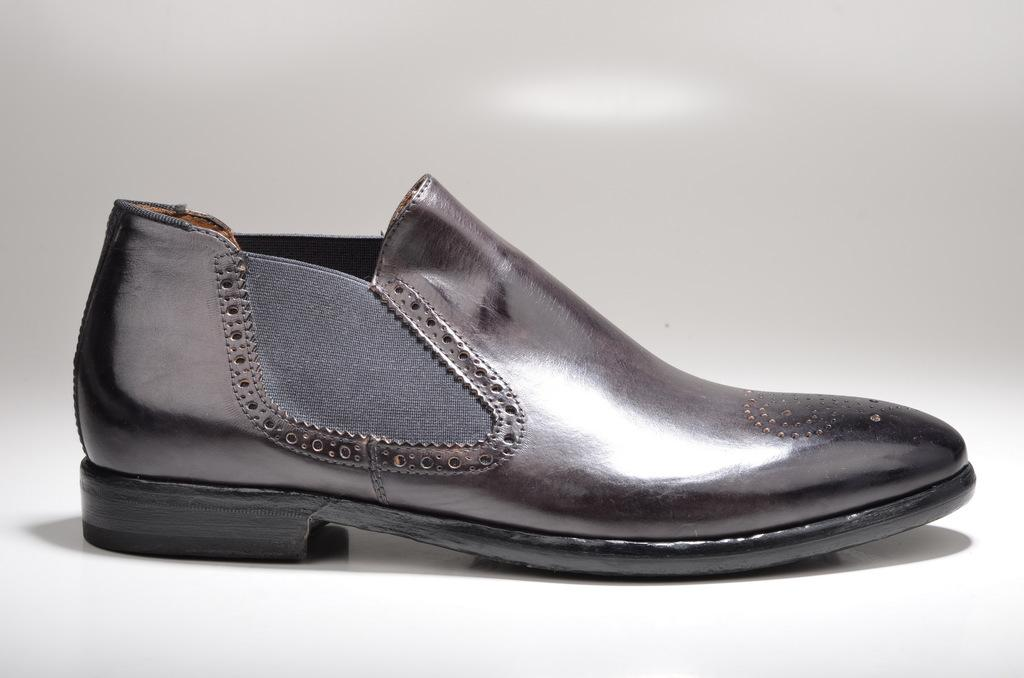What object is the main subject of the image? There is a shoe in the image. Can you describe the appearance of the shoe's shadow? The shadow of the shoe is visible on a white surface. How does the beginner worm interact with the shoe in the image? There is no beginner worm present in the image, and therefore no interaction can be observed. 